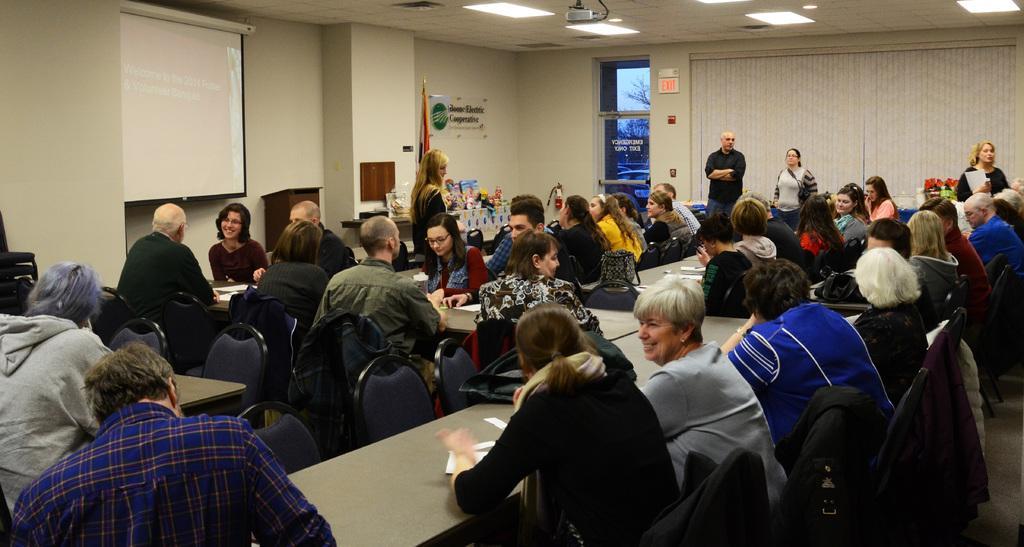Can you describe this image briefly? In this picture there are a group of people sitting, they have a table in front of them they are also some papers kept on it and there is a projector screen over here and is a projector attached to the ceiling and on the right there is a wall and a door 